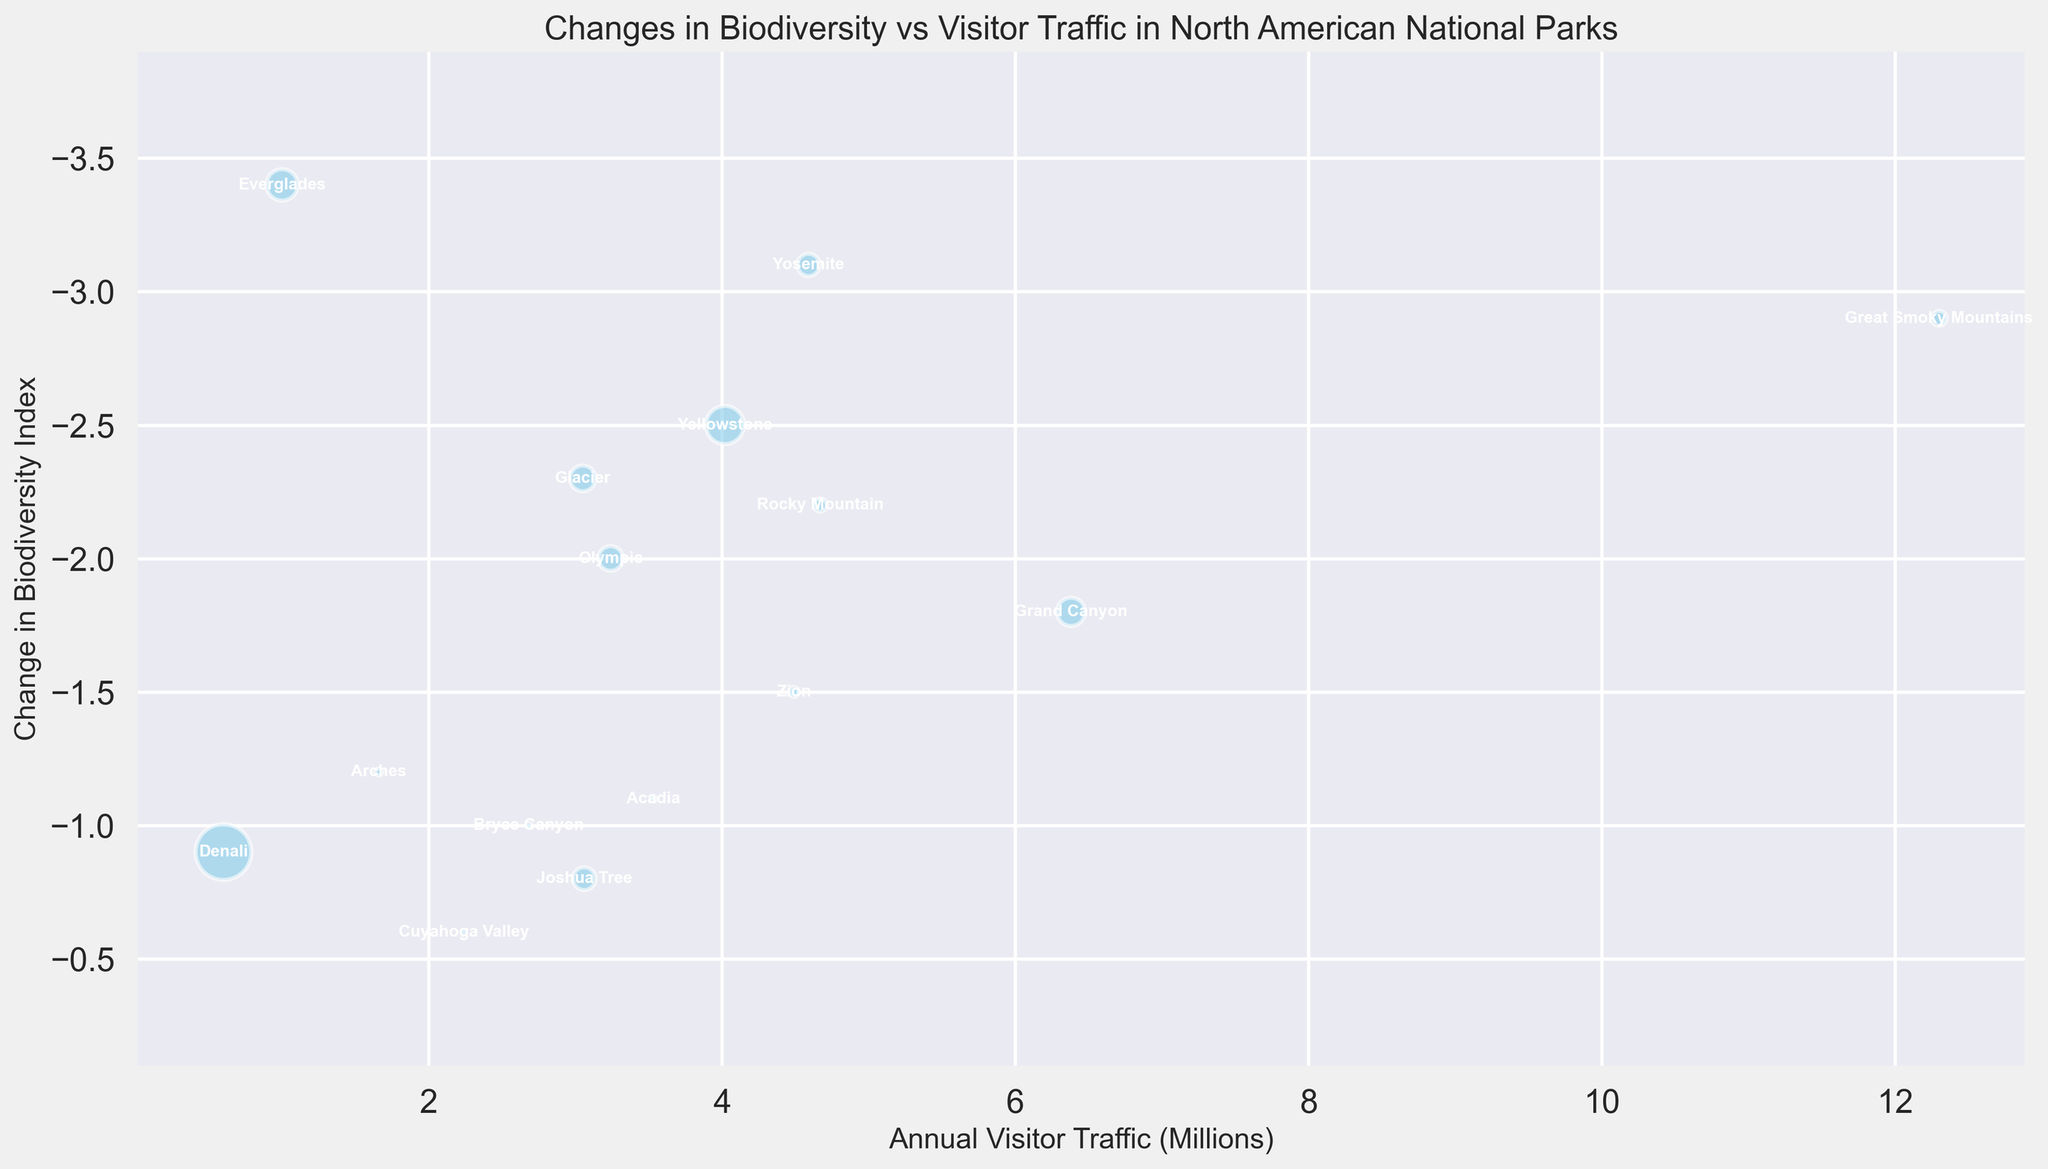Which park has the highest annual visitor traffic and what is its change in biodiversity index? From the figure, we can identify the park by looking at the bubble furthest to the right, which represents the highest annual visitor traffic. Grand Canyon in Arizona has the highest visitor traffic. The change in biodiversity index is represented by the y-axis value associated with Grand Canyon.
Answer: Grand Canyon, -1.8 Which park has the smallest area, and what is its annual visitor traffic? By observing the figure, the smallest bubbles represent the smallest park areas. The smallest bubble corresponds to Bryce Canyon in Utah. The annual visitor traffic is represented on the x-axis.
Answer: Bryce Canyon, 2.68 million Which park has the most significant negative change in biodiversity index, and how many visitors does it receive annually? To determine the most significant negative change in biodiversity index, look for the bubble that is positioned lowest on the y-axis. This bubble belongs to Everglades in Florida. The annual visitor traffic is recorded on the x-axis.
Answer: Everglades, 1.00 million How does the size of the bubble for Denali compare to that of Yellowstone? The size of the bubble indicates the park area. Denali's bubble should be significantly larger compared to Yellowstone's due to Denali’s extensive area.
Answer: Denali's bubble is larger Which two parks have the closest change in biodiversity index, and what are their respective visitor traffics? Examine the y-axis for closely aligned bubble centers. Olympic and Glacier both have a change in biodiversity index of around -2.0. Their annual visitor traffics are given on the x-axis.
Answer: Olympic (3.24 million), Glacier (3.05 million) What is the average annual visitor traffic of the parks in California? Add the annual visitor traffic of Yosemite (4.59 million), Joshua Tree (3.06 million), and divide by the number of parks (2). (4.59 + 3.06)/2 = 7.65/2
Answer: 3.83 million Which park in Utah has a lesser change in biodiversity index, and what is its annual visitor traffic? Compare the y-axis values of the Utah parks. Zion, with a change of -1.5, has a lesser change compared to Bryce Canyon and Arches. The annual visitor traffic for Zion is indicated on the x-axis.
Answer: Zion, 4.49 million How does the park area for Great Smoky Mountains compare to Yellowstone, and what are their changes in biodiversity index? The bubble sizes indicate the park areas. Great Smoky Mountains has a smaller bubble size than Yellowstone. Their changes in biodiversity index are visible on the y-axis.
Answer: Great Smoky Mountains is smaller, -2.9 and -2.5 What is the combined change in biodiversity index of the two parks with the least visitor traffic? Identify the two parks with the least traffic from the x-axis, which are Everglades and Denali. Sum their biodiversity changes: -3.4 (Everglades) + -0.9 (Denali) = -4.3
Answer: -4.3 Which park with a visitor traffic above 4 million has the least negative change in biodiversity index? Look at the bubbles to the right of the 4 million mark on the x-axis and find the one closest to the top on the y-axis for the least negative change. Zion from Utah fits this criterion.
Answer: Zion 